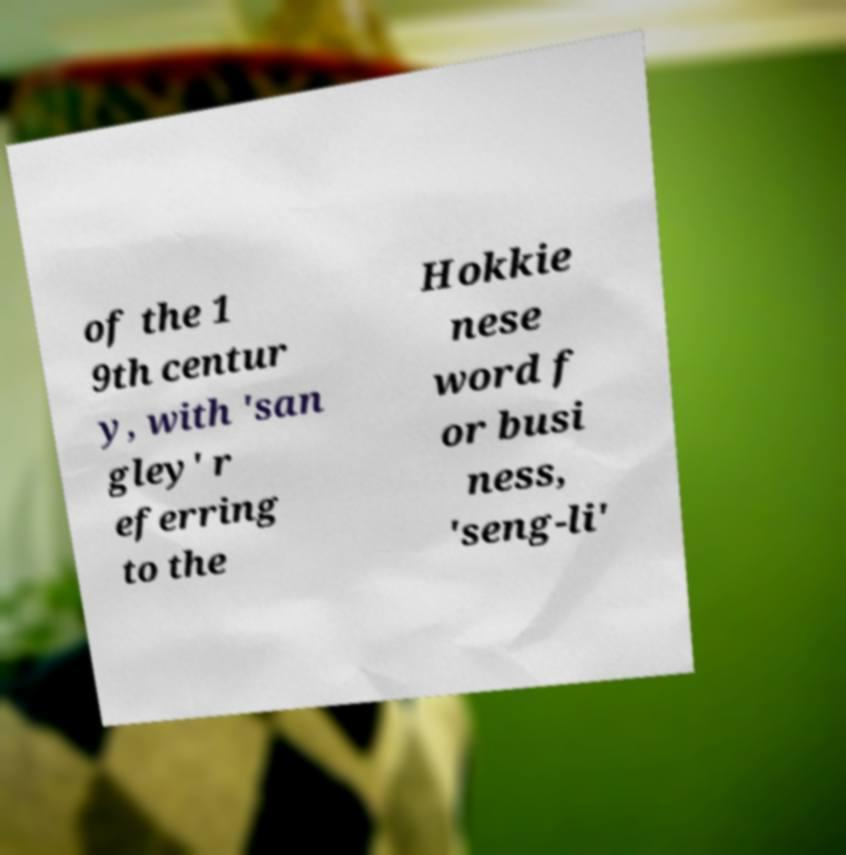What messages or text are displayed in this image? I need them in a readable, typed format. of the 1 9th centur y, with 'san gley' r eferring to the Hokkie nese word f or busi ness, 'seng-li' 